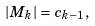<formula> <loc_0><loc_0><loc_500><loc_500>| M _ { k } | = c _ { k - 1 } ,</formula> 